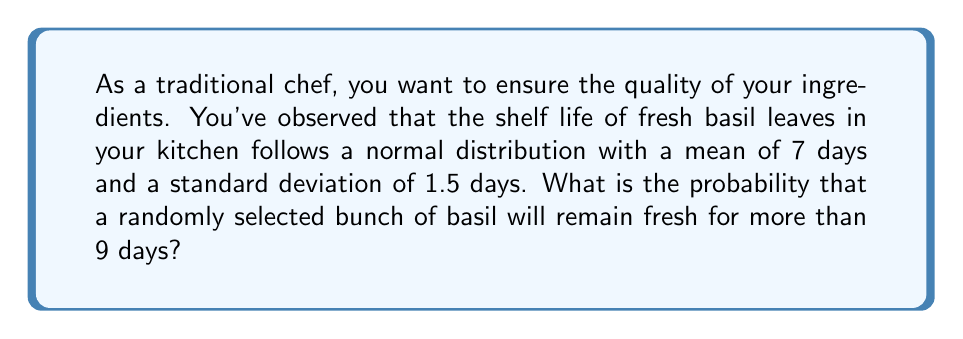Teach me how to tackle this problem. To solve this problem, we'll use the properties of the normal distribution and the z-score formula.

Step 1: Identify the given information
- The shelf life of basil follows a normal distribution
- Mean (μ) = 7 days
- Standard deviation (σ) = 1.5 days
- We want to find P(X > 9), where X is the shelf life in days

Step 2: Calculate the z-score for 9 days
The z-score formula is:
$z = \frac{x - \mu}{\sigma}$

Plugging in the values:
$z = \frac{9 - 7}{1.5} = \frac{2}{1.5} \approx 1.33$

Step 3: Find the probability using the standard normal distribution table
We need to find P(Z > 1.33), where Z is the standard normal variable.

Using a standard normal distribution table or calculator:
P(Z > 1.33) ≈ 0.0918

Step 4: Interpret the result
The probability that a randomly selected bunch of basil will remain fresh for more than 9 days is approximately 0.0918 or 9.18%.
Answer: 0.0918 or 9.18% 